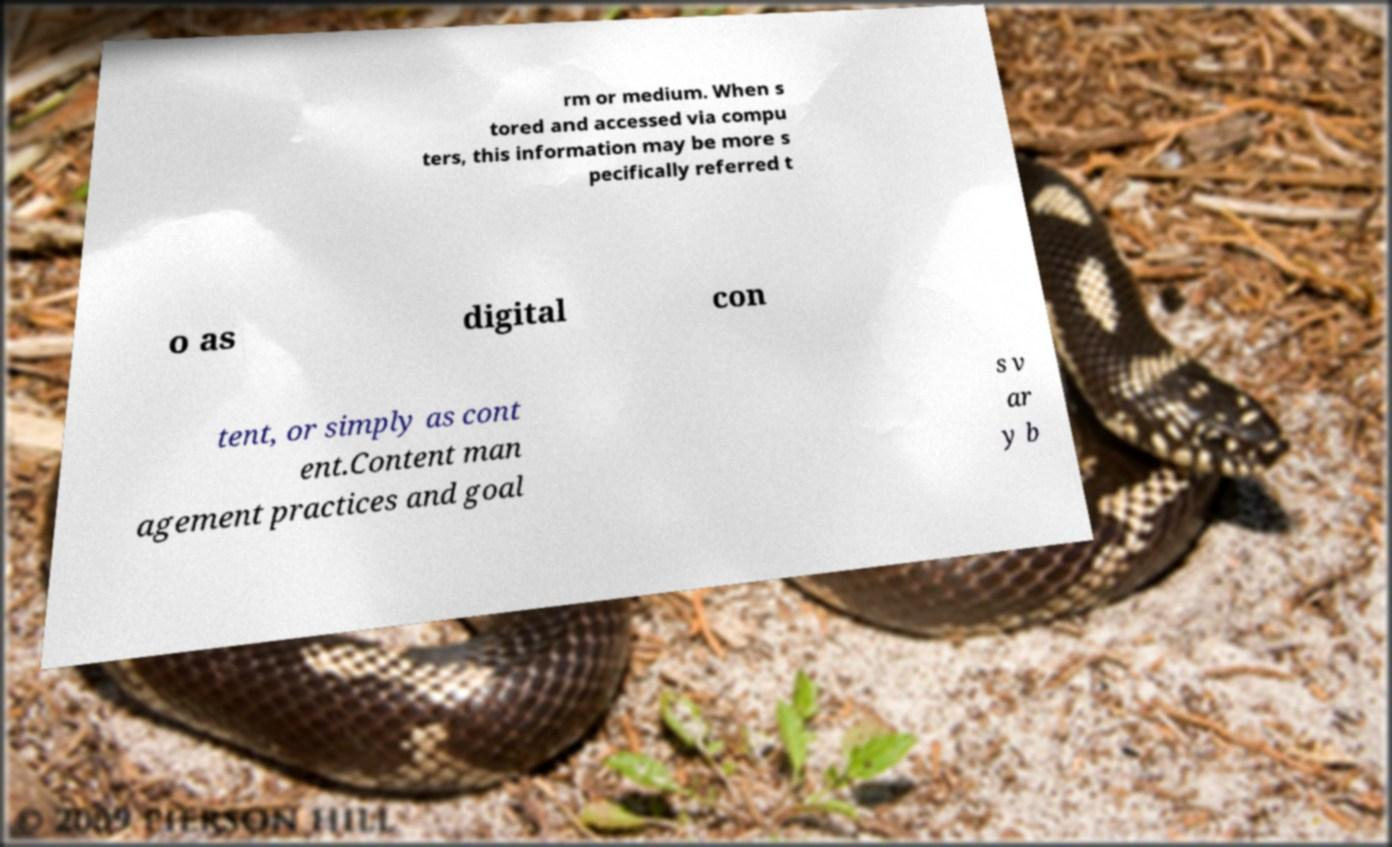Could you extract and type out the text from this image? rm or medium. When s tored and accessed via compu ters, this information may be more s pecifically referred t o as digital con tent, or simply as cont ent.Content man agement practices and goal s v ar y b 